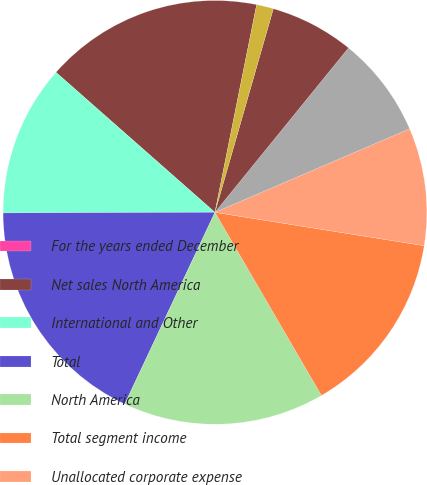Convert chart to OTSL. <chart><loc_0><loc_0><loc_500><loc_500><pie_chart><fcel>For the years ended December<fcel>Net sales North America<fcel>International and Other<fcel>Total<fcel>North America<fcel>Total segment income<fcel>Unallocated corporate expense<fcel>Goodwill and other intangible<fcel>Costs associated with business<fcel>Non-service related pension<nl><fcel>0.0%<fcel>16.66%<fcel>11.54%<fcel>17.95%<fcel>15.38%<fcel>14.1%<fcel>8.97%<fcel>7.69%<fcel>6.41%<fcel>1.29%<nl></chart> 